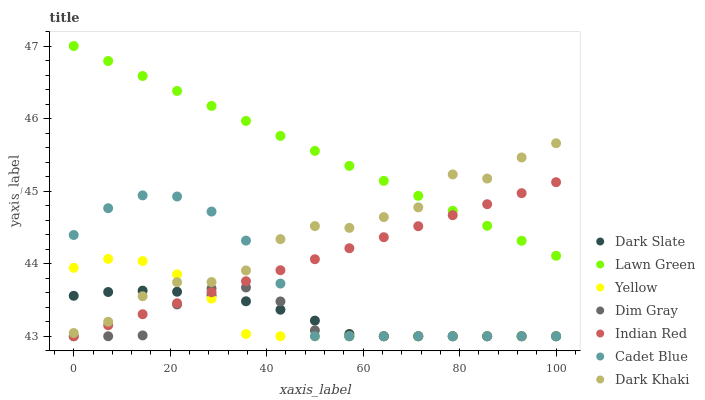Does Dim Gray have the minimum area under the curve?
Answer yes or no. Yes. Does Lawn Green have the maximum area under the curve?
Answer yes or no. Yes. Does Cadet Blue have the minimum area under the curve?
Answer yes or no. No. Does Cadet Blue have the maximum area under the curve?
Answer yes or no. No. Is Lawn Green the smoothest?
Answer yes or no. Yes. Is Dark Khaki the roughest?
Answer yes or no. Yes. Is Cadet Blue the smoothest?
Answer yes or no. No. Is Cadet Blue the roughest?
Answer yes or no. No. Does Cadet Blue have the lowest value?
Answer yes or no. Yes. Does Dark Khaki have the lowest value?
Answer yes or no. No. Does Lawn Green have the highest value?
Answer yes or no. Yes. Does Cadet Blue have the highest value?
Answer yes or no. No. Is Cadet Blue less than Lawn Green?
Answer yes or no. Yes. Is Lawn Green greater than Dark Slate?
Answer yes or no. Yes. Does Dim Gray intersect Dark Slate?
Answer yes or no. Yes. Is Dim Gray less than Dark Slate?
Answer yes or no. No. Is Dim Gray greater than Dark Slate?
Answer yes or no. No. Does Cadet Blue intersect Lawn Green?
Answer yes or no. No. 